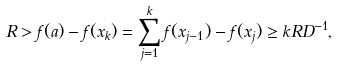Convert formula to latex. <formula><loc_0><loc_0><loc_500><loc_500>R > f ( a ) - f ( x _ { k } ) = \sum _ { j = 1 } ^ { k } f ( x _ { j - 1 } ) - f ( x _ { j } ) \geq k R D ^ { - 1 } ,</formula> 